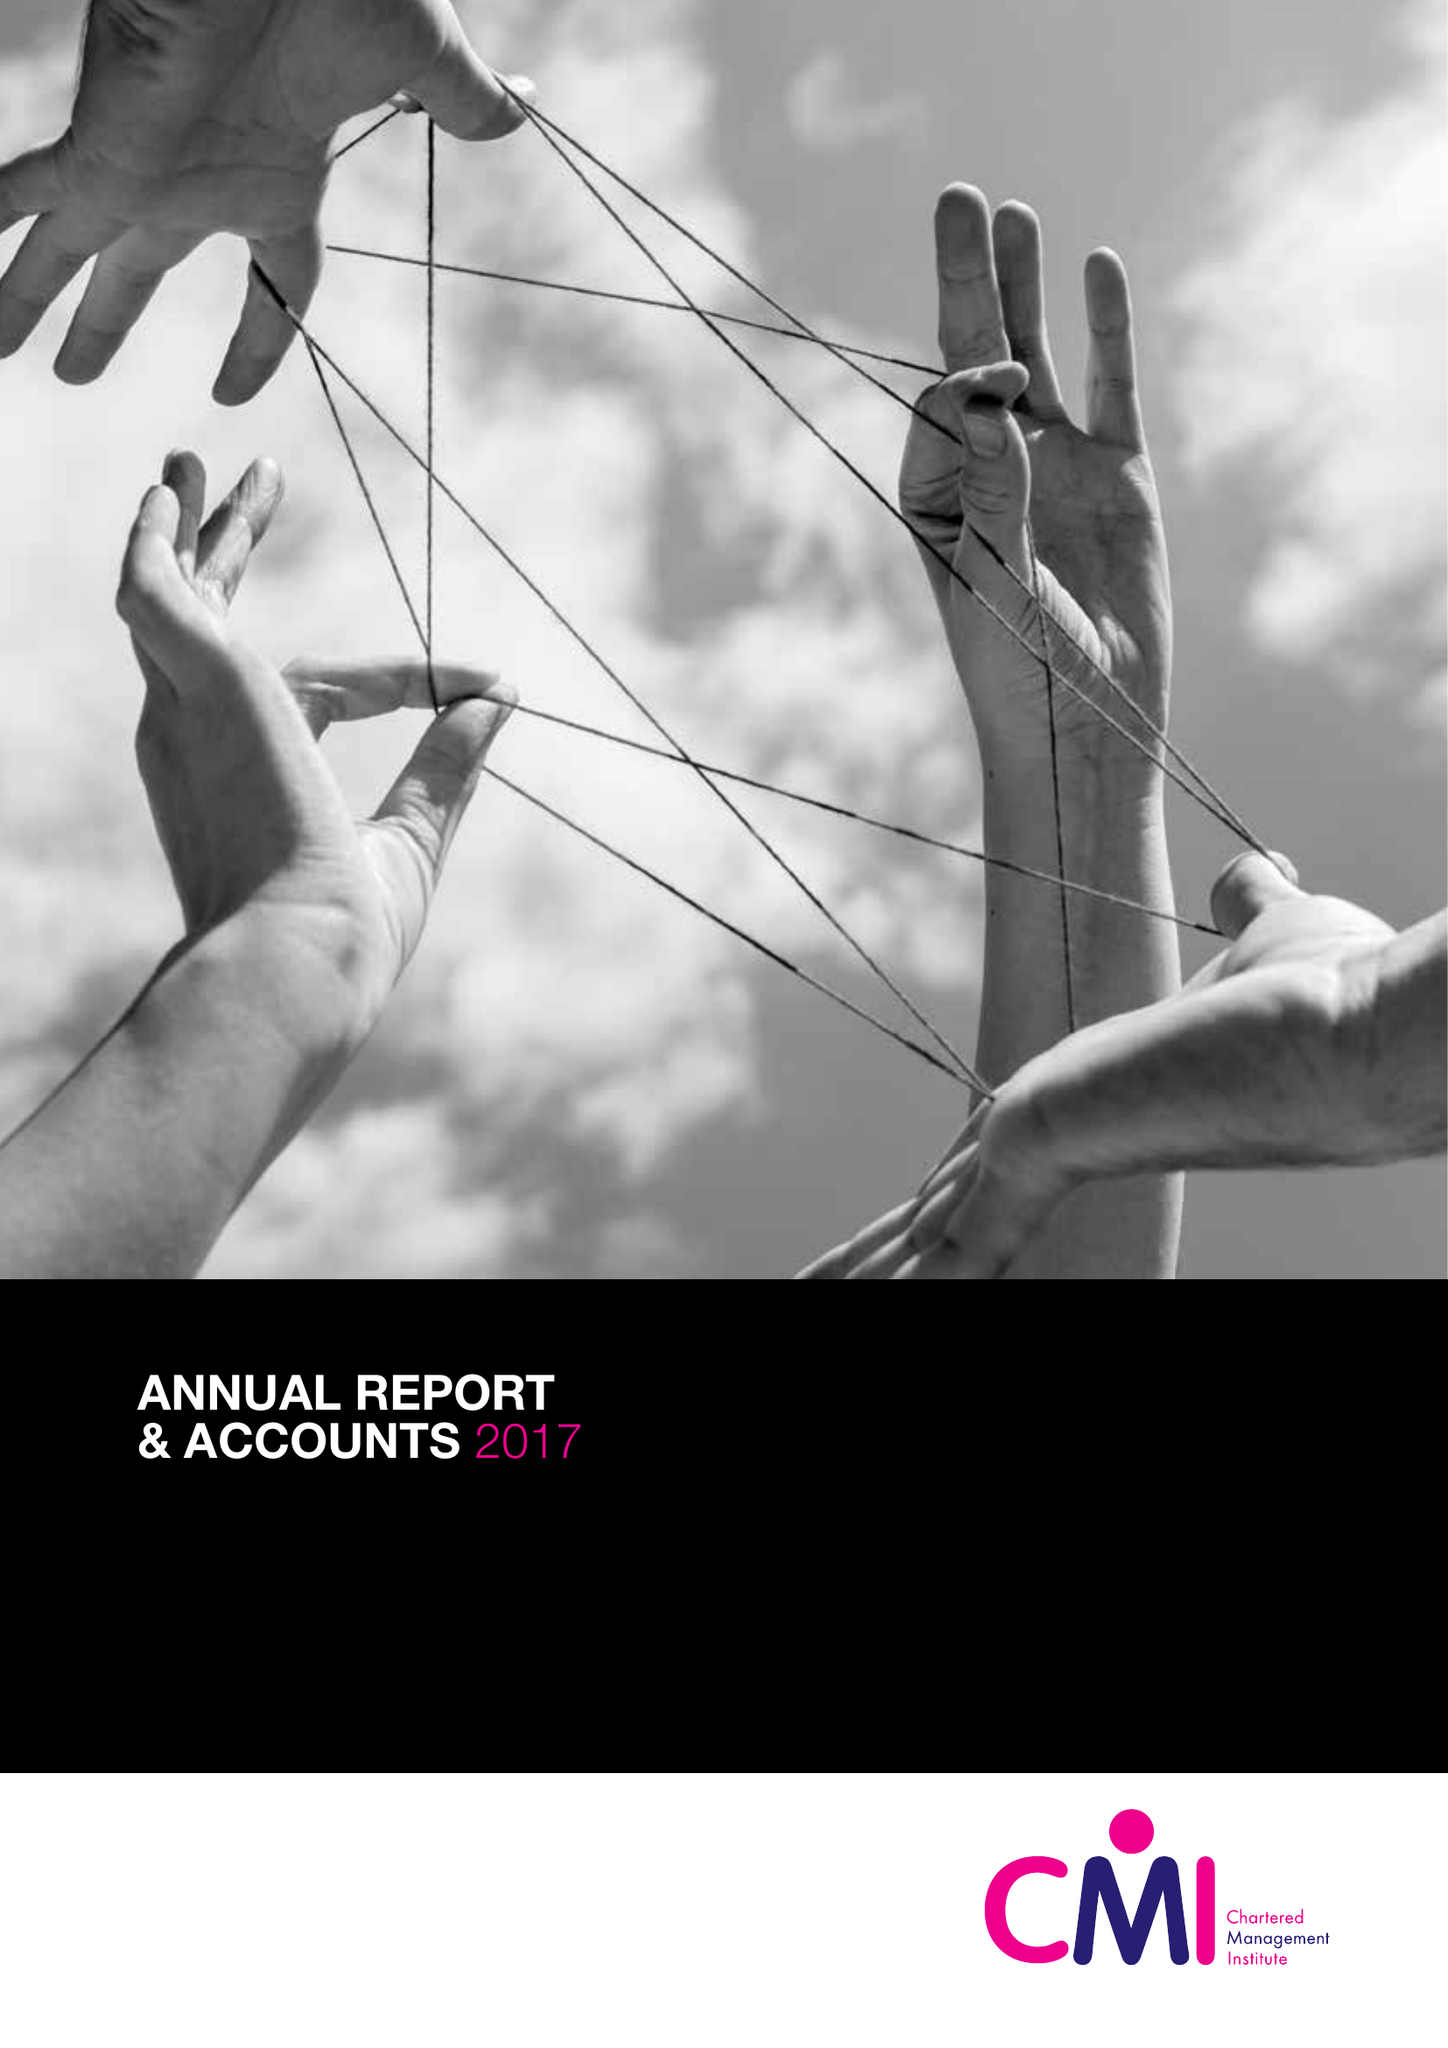What is the value for the address__street_line?
Answer the question using a single word or phrase. COTTINGHAM ROAD 